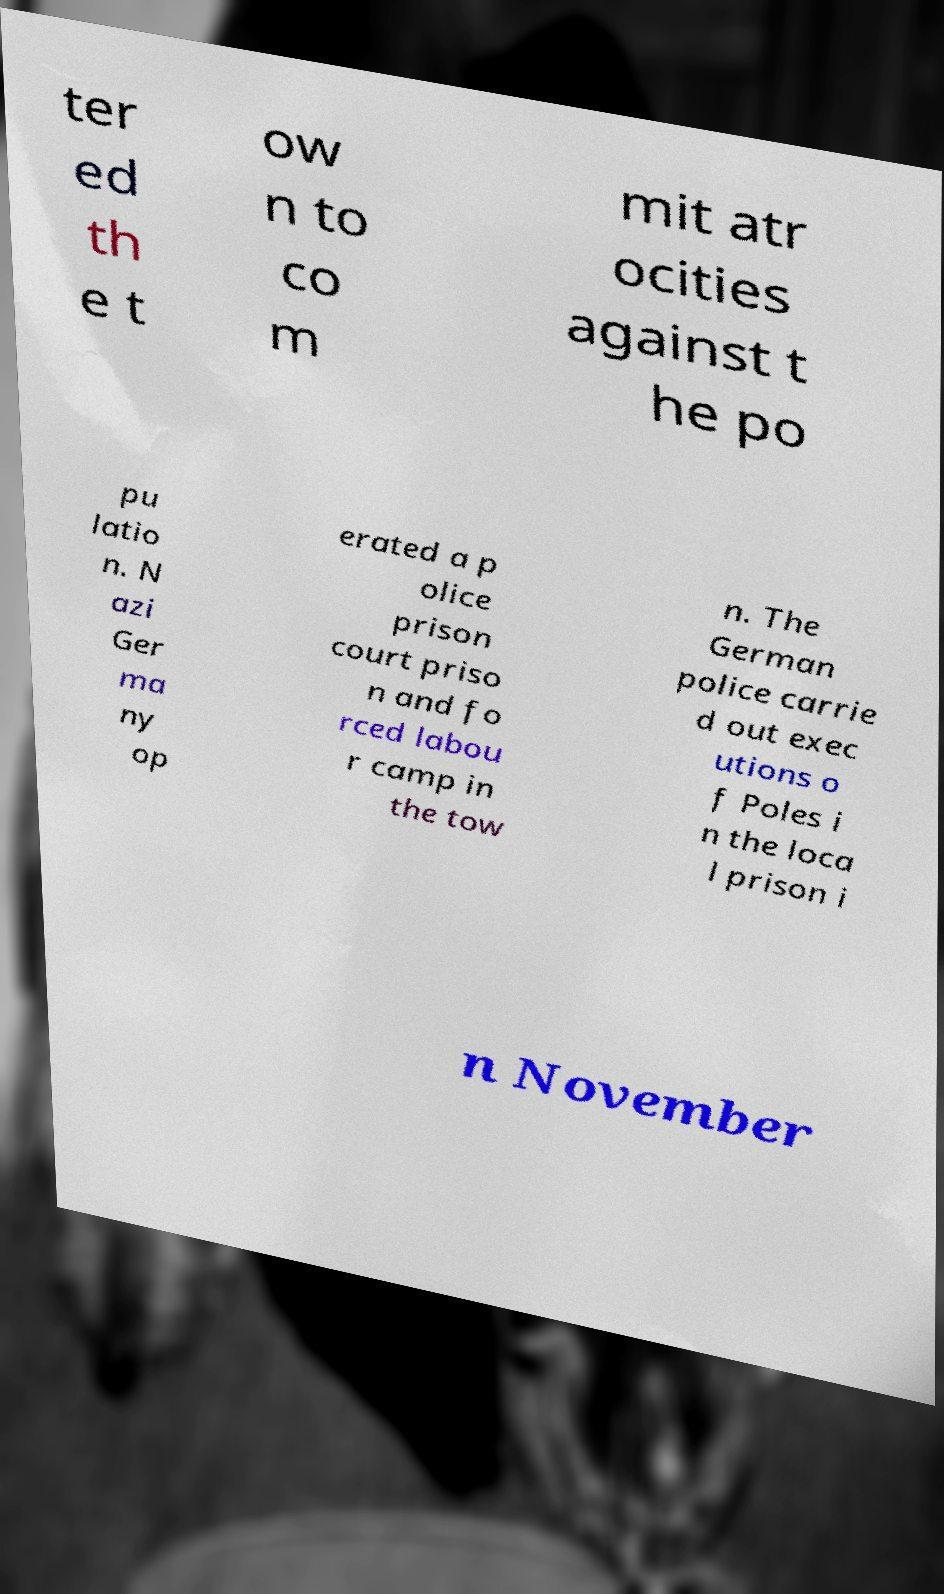Could you extract and type out the text from this image? ter ed th e t ow n to co m mit atr ocities against t he po pu latio n. N azi Ger ma ny op erated a p olice prison court priso n and fo rced labou r camp in the tow n. The German police carrie d out exec utions o f Poles i n the loca l prison i n November 